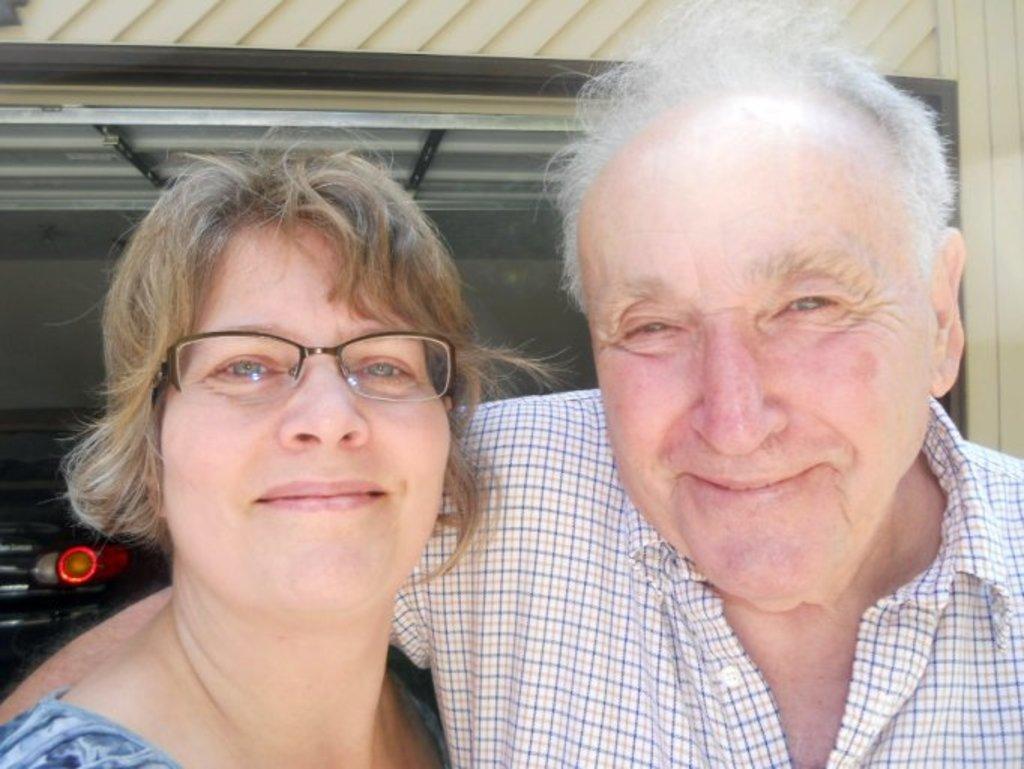Could you give a brief overview of what you see in this image? In this image I can see two people with different color dresses. I can see one person wearing the specs. In the back I can see the car inside the shed. 